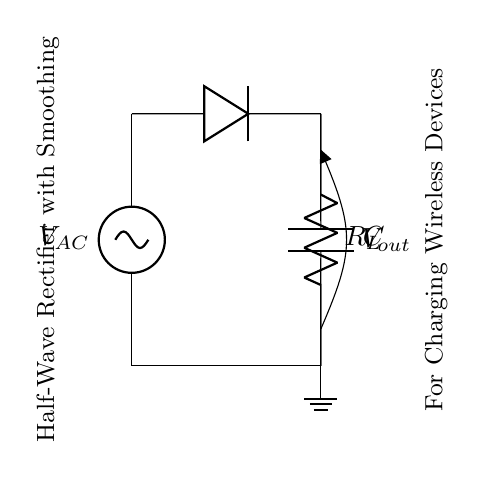What type of rectifier is shown in the diagram? The diagram depicts a half-wave rectifier, which is evident from the presence of a single diode allowing current to pass only during one half of the AC cycle.
Answer: Half-wave rectifier What component smooths the output voltage? The smoothing capacitor is connected in parallel with the load resistor and is crucial for reducing voltage ripple by storing energy and releasing it when the voltage drops.
Answer: Capacitor What is the role of the diode in this circuit? The diode allows current to flow in only one direction, blocking the reverse flow. This mechanism is fundamental to converting AC voltage to a unidirectional output.
Answer: Converting AC to DC What happens to the output voltage when the load resistance increases? Increasing the load resistance reduces the output current, which generally results in a higher output voltage across the load, assuming the rectifier maintains its operation within the specified limits.
Answer: Increases What components limit the flow of current to the wireless devices? The resistor limits the amount of current flowing to the load, which is critical for ensuring that the wireless communication devices do not draw excessive current that could damage them.
Answer: Resistor How would the waveform of the output voltage appear? The output voltage waveform would show only the positive half-cycles of the AC input with a noticeable ripple caused by the capacitor discharging between these cycles.
Answer: Positive half-cycles What is the purpose of the AC source in this circuit? The AC source provides the initial alternating voltage necessary for the rectification process, allowing the diode to convert it into direct current for the load.
Answer: Supply input voltage 